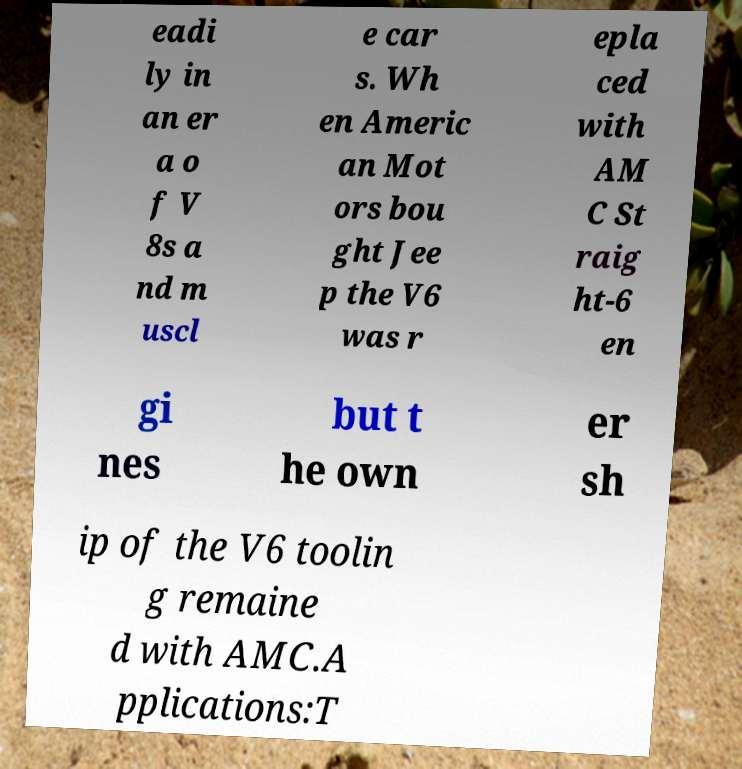Could you extract and type out the text from this image? eadi ly in an er a o f V 8s a nd m uscl e car s. Wh en Americ an Mot ors bou ght Jee p the V6 was r epla ced with AM C St raig ht-6 en gi nes but t he own er sh ip of the V6 toolin g remaine d with AMC.A pplications:T 